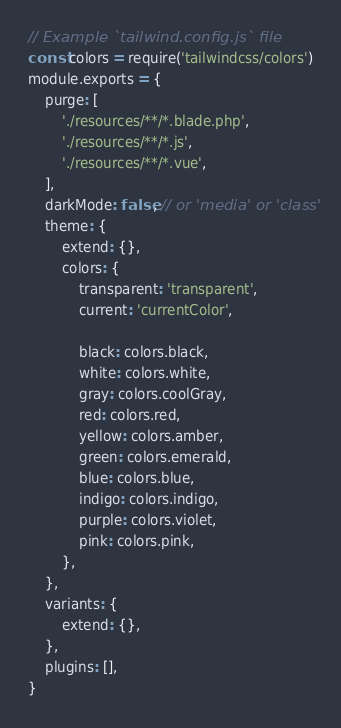<code> <loc_0><loc_0><loc_500><loc_500><_JavaScript_>// Example `tailwind.config.js` file
const colors = require('tailwindcss/colors')
module.exports = {
    purge: [
        './resources/**/*.blade.php',
        './resources/**/*.js',
        './resources/**/*.vue',
    ],
    darkMode: false, // or 'media' or 'class'
    theme: {
        extend: {},
        colors: {
            transparent: 'transparent',
            current: 'currentColor',

            black: colors.black,
            white: colors.white,
            gray: colors.coolGray,
            red: colors.red,
            yellow: colors.amber,
            green: colors.emerald,
            blue: colors.blue,
            indigo: colors.indigo,
            purple: colors.violet,
            pink: colors.pink,
        },
    },
    variants: {
        extend: {},
    },
    plugins: [],
}
</code> 